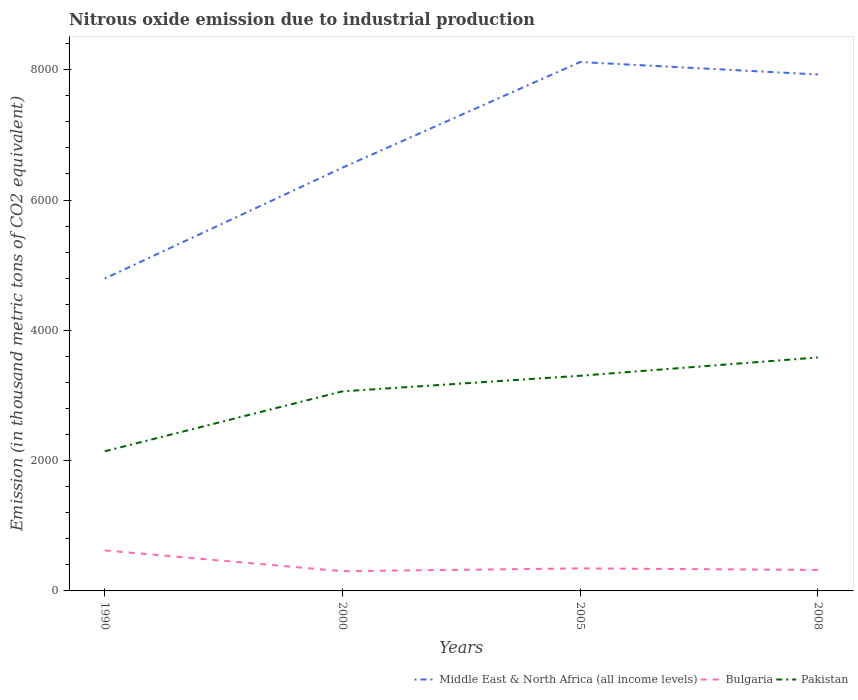How many different coloured lines are there?
Make the answer very short. 3. Is the number of lines equal to the number of legend labels?
Give a very brief answer. Yes. Across all years, what is the maximum amount of nitrous oxide emitted in Bulgaria?
Give a very brief answer. 302.6. In which year was the amount of nitrous oxide emitted in Bulgaria maximum?
Your response must be concise. 2000. What is the total amount of nitrous oxide emitted in Bulgaria in the graph?
Your answer should be compact. -19.4. What is the difference between the highest and the second highest amount of nitrous oxide emitted in Bulgaria?
Make the answer very short. 319.4. What is the difference between the highest and the lowest amount of nitrous oxide emitted in Pakistan?
Ensure brevity in your answer.  3. What is the difference between two consecutive major ticks on the Y-axis?
Make the answer very short. 2000. Are the values on the major ticks of Y-axis written in scientific E-notation?
Make the answer very short. No. Does the graph contain any zero values?
Ensure brevity in your answer.  No. What is the title of the graph?
Your response must be concise. Nitrous oxide emission due to industrial production. What is the label or title of the X-axis?
Provide a succinct answer. Years. What is the label or title of the Y-axis?
Your answer should be very brief. Emission (in thousand metric tons of CO2 equivalent). What is the Emission (in thousand metric tons of CO2 equivalent) in Middle East & North Africa (all income levels) in 1990?
Offer a very short reply. 4795.2. What is the Emission (in thousand metric tons of CO2 equivalent) in Bulgaria in 1990?
Your answer should be very brief. 622. What is the Emission (in thousand metric tons of CO2 equivalent) in Pakistan in 1990?
Offer a terse response. 2143.8. What is the Emission (in thousand metric tons of CO2 equivalent) of Middle East & North Africa (all income levels) in 2000?
Your answer should be very brief. 6497. What is the Emission (in thousand metric tons of CO2 equivalent) of Bulgaria in 2000?
Provide a short and direct response. 302.6. What is the Emission (in thousand metric tons of CO2 equivalent) in Pakistan in 2000?
Offer a terse response. 3063.5. What is the Emission (in thousand metric tons of CO2 equivalent) in Middle East & North Africa (all income levels) in 2005?
Provide a succinct answer. 8118.6. What is the Emission (in thousand metric tons of CO2 equivalent) of Bulgaria in 2005?
Your answer should be very brief. 345.8. What is the Emission (in thousand metric tons of CO2 equivalent) of Pakistan in 2005?
Keep it short and to the point. 3302.9. What is the Emission (in thousand metric tons of CO2 equivalent) of Middle East & North Africa (all income levels) in 2008?
Offer a terse response. 7927.7. What is the Emission (in thousand metric tons of CO2 equivalent) in Bulgaria in 2008?
Your response must be concise. 322. What is the Emission (in thousand metric tons of CO2 equivalent) in Pakistan in 2008?
Your answer should be compact. 3584. Across all years, what is the maximum Emission (in thousand metric tons of CO2 equivalent) in Middle East & North Africa (all income levels)?
Make the answer very short. 8118.6. Across all years, what is the maximum Emission (in thousand metric tons of CO2 equivalent) of Bulgaria?
Offer a very short reply. 622. Across all years, what is the maximum Emission (in thousand metric tons of CO2 equivalent) in Pakistan?
Your answer should be very brief. 3584. Across all years, what is the minimum Emission (in thousand metric tons of CO2 equivalent) in Middle East & North Africa (all income levels)?
Give a very brief answer. 4795.2. Across all years, what is the minimum Emission (in thousand metric tons of CO2 equivalent) of Bulgaria?
Offer a terse response. 302.6. Across all years, what is the minimum Emission (in thousand metric tons of CO2 equivalent) of Pakistan?
Your response must be concise. 2143.8. What is the total Emission (in thousand metric tons of CO2 equivalent) in Middle East & North Africa (all income levels) in the graph?
Your answer should be compact. 2.73e+04. What is the total Emission (in thousand metric tons of CO2 equivalent) of Bulgaria in the graph?
Your response must be concise. 1592.4. What is the total Emission (in thousand metric tons of CO2 equivalent) in Pakistan in the graph?
Your answer should be very brief. 1.21e+04. What is the difference between the Emission (in thousand metric tons of CO2 equivalent) of Middle East & North Africa (all income levels) in 1990 and that in 2000?
Provide a succinct answer. -1701.8. What is the difference between the Emission (in thousand metric tons of CO2 equivalent) of Bulgaria in 1990 and that in 2000?
Offer a very short reply. 319.4. What is the difference between the Emission (in thousand metric tons of CO2 equivalent) of Pakistan in 1990 and that in 2000?
Your response must be concise. -919.7. What is the difference between the Emission (in thousand metric tons of CO2 equivalent) of Middle East & North Africa (all income levels) in 1990 and that in 2005?
Make the answer very short. -3323.4. What is the difference between the Emission (in thousand metric tons of CO2 equivalent) of Bulgaria in 1990 and that in 2005?
Ensure brevity in your answer.  276.2. What is the difference between the Emission (in thousand metric tons of CO2 equivalent) of Pakistan in 1990 and that in 2005?
Your answer should be very brief. -1159.1. What is the difference between the Emission (in thousand metric tons of CO2 equivalent) in Middle East & North Africa (all income levels) in 1990 and that in 2008?
Keep it short and to the point. -3132.5. What is the difference between the Emission (in thousand metric tons of CO2 equivalent) of Bulgaria in 1990 and that in 2008?
Make the answer very short. 300. What is the difference between the Emission (in thousand metric tons of CO2 equivalent) of Pakistan in 1990 and that in 2008?
Give a very brief answer. -1440.2. What is the difference between the Emission (in thousand metric tons of CO2 equivalent) in Middle East & North Africa (all income levels) in 2000 and that in 2005?
Keep it short and to the point. -1621.6. What is the difference between the Emission (in thousand metric tons of CO2 equivalent) of Bulgaria in 2000 and that in 2005?
Your answer should be compact. -43.2. What is the difference between the Emission (in thousand metric tons of CO2 equivalent) in Pakistan in 2000 and that in 2005?
Offer a very short reply. -239.4. What is the difference between the Emission (in thousand metric tons of CO2 equivalent) in Middle East & North Africa (all income levels) in 2000 and that in 2008?
Your answer should be compact. -1430.7. What is the difference between the Emission (in thousand metric tons of CO2 equivalent) in Bulgaria in 2000 and that in 2008?
Offer a very short reply. -19.4. What is the difference between the Emission (in thousand metric tons of CO2 equivalent) in Pakistan in 2000 and that in 2008?
Keep it short and to the point. -520.5. What is the difference between the Emission (in thousand metric tons of CO2 equivalent) in Middle East & North Africa (all income levels) in 2005 and that in 2008?
Offer a terse response. 190.9. What is the difference between the Emission (in thousand metric tons of CO2 equivalent) in Bulgaria in 2005 and that in 2008?
Offer a terse response. 23.8. What is the difference between the Emission (in thousand metric tons of CO2 equivalent) of Pakistan in 2005 and that in 2008?
Your answer should be very brief. -281.1. What is the difference between the Emission (in thousand metric tons of CO2 equivalent) of Middle East & North Africa (all income levels) in 1990 and the Emission (in thousand metric tons of CO2 equivalent) of Bulgaria in 2000?
Ensure brevity in your answer.  4492.6. What is the difference between the Emission (in thousand metric tons of CO2 equivalent) of Middle East & North Africa (all income levels) in 1990 and the Emission (in thousand metric tons of CO2 equivalent) of Pakistan in 2000?
Keep it short and to the point. 1731.7. What is the difference between the Emission (in thousand metric tons of CO2 equivalent) of Bulgaria in 1990 and the Emission (in thousand metric tons of CO2 equivalent) of Pakistan in 2000?
Your answer should be compact. -2441.5. What is the difference between the Emission (in thousand metric tons of CO2 equivalent) in Middle East & North Africa (all income levels) in 1990 and the Emission (in thousand metric tons of CO2 equivalent) in Bulgaria in 2005?
Make the answer very short. 4449.4. What is the difference between the Emission (in thousand metric tons of CO2 equivalent) of Middle East & North Africa (all income levels) in 1990 and the Emission (in thousand metric tons of CO2 equivalent) of Pakistan in 2005?
Your answer should be compact. 1492.3. What is the difference between the Emission (in thousand metric tons of CO2 equivalent) of Bulgaria in 1990 and the Emission (in thousand metric tons of CO2 equivalent) of Pakistan in 2005?
Provide a succinct answer. -2680.9. What is the difference between the Emission (in thousand metric tons of CO2 equivalent) in Middle East & North Africa (all income levels) in 1990 and the Emission (in thousand metric tons of CO2 equivalent) in Bulgaria in 2008?
Offer a terse response. 4473.2. What is the difference between the Emission (in thousand metric tons of CO2 equivalent) in Middle East & North Africa (all income levels) in 1990 and the Emission (in thousand metric tons of CO2 equivalent) in Pakistan in 2008?
Your response must be concise. 1211.2. What is the difference between the Emission (in thousand metric tons of CO2 equivalent) in Bulgaria in 1990 and the Emission (in thousand metric tons of CO2 equivalent) in Pakistan in 2008?
Offer a terse response. -2962. What is the difference between the Emission (in thousand metric tons of CO2 equivalent) in Middle East & North Africa (all income levels) in 2000 and the Emission (in thousand metric tons of CO2 equivalent) in Bulgaria in 2005?
Keep it short and to the point. 6151.2. What is the difference between the Emission (in thousand metric tons of CO2 equivalent) of Middle East & North Africa (all income levels) in 2000 and the Emission (in thousand metric tons of CO2 equivalent) of Pakistan in 2005?
Your response must be concise. 3194.1. What is the difference between the Emission (in thousand metric tons of CO2 equivalent) in Bulgaria in 2000 and the Emission (in thousand metric tons of CO2 equivalent) in Pakistan in 2005?
Ensure brevity in your answer.  -3000.3. What is the difference between the Emission (in thousand metric tons of CO2 equivalent) of Middle East & North Africa (all income levels) in 2000 and the Emission (in thousand metric tons of CO2 equivalent) of Bulgaria in 2008?
Offer a terse response. 6175. What is the difference between the Emission (in thousand metric tons of CO2 equivalent) of Middle East & North Africa (all income levels) in 2000 and the Emission (in thousand metric tons of CO2 equivalent) of Pakistan in 2008?
Offer a terse response. 2913. What is the difference between the Emission (in thousand metric tons of CO2 equivalent) in Bulgaria in 2000 and the Emission (in thousand metric tons of CO2 equivalent) in Pakistan in 2008?
Your answer should be compact. -3281.4. What is the difference between the Emission (in thousand metric tons of CO2 equivalent) in Middle East & North Africa (all income levels) in 2005 and the Emission (in thousand metric tons of CO2 equivalent) in Bulgaria in 2008?
Your response must be concise. 7796.6. What is the difference between the Emission (in thousand metric tons of CO2 equivalent) of Middle East & North Africa (all income levels) in 2005 and the Emission (in thousand metric tons of CO2 equivalent) of Pakistan in 2008?
Provide a short and direct response. 4534.6. What is the difference between the Emission (in thousand metric tons of CO2 equivalent) of Bulgaria in 2005 and the Emission (in thousand metric tons of CO2 equivalent) of Pakistan in 2008?
Give a very brief answer. -3238.2. What is the average Emission (in thousand metric tons of CO2 equivalent) in Middle East & North Africa (all income levels) per year?
Provide a succinct answer. 6834.62. What is the average Emission (in thousand metric tons of CO2 equivalent) of Bulgaria per year?
Provide a short and direct response. 398.1. What is the average Emission (in thousand metric tons of CO2 equivalent) in Pakistan per year?
Offer a very short reply. 3023.55. In the year 1990, what is the difference between the Emission (in thousand metric tons of CO2 equivalent) of Middle East & North Africa (all income levels) and Emission (in thousand metric tons of CO2 equivalent) of Bulgaria?
Offer a very short reply. 4173.2. In the year 1990, what is the difference between the Emission (in thousand metric tons of CO2 equivalent) in Middle East & North Africa (all income levels) and Emission (in thousand metric tons of CO2 equivalent) in Pakistan?
Give a very brief answer. 2651.4. In the year 1990, what is the difference between the Emission (in thousand metric tons of CO2 equivalent) in Bulgaria and Emission (in thousand metric tons of CO2 equivalent) in Pakistan?
Offer a very short reply. -1521.8. In the year 2000, what is the difference between the Emission (in thousand metric tons of CO2 equivalent) of Middle East & North Africa (all income levels) and Emission (in thousand metric tons of CO2 equivalent) of Bulgaria?
Give a very brief answer. 6194.4. In the year 2000, what is the difference between the Emission (in thousand metric tons of CO2 equivalent) in Middle East & North Africa (all income levels) and Emission (in thousand metric tons of CO2 equivalent) in Pakistan?
Your answer should be very brief. 3433.5. In the year 2000, what is the difference between the Emission (in thousand metric tons of CO2 equivalent) of Bulgaria and Emission (in thousand metric tons of CO2 equivalent) of Pakistan?
Make the answer very short. -2760.9. In the year 2005, what is the difference between the Emission (in thousand metric tons of CO2 equivalent) of Middle East & North Africa (all income levels) and Emission (in thousand metric tons of CO2 equivalent) of Bulgaria?
Your response must be concise. 7772.8. In the year 2005, what is the difference between the Emission (in thousand metric tons of CO2 equivalent) of Middle East & North Africa (all income levels) and Emission (in thousand metric tons of CO2 equivalent) of Pakistan?
Make the answer very short. 4815.7. In the year 2005, what is the difference between the Emission (in thousand metric tons of CO2 equivalent) of Bulgaria and Emission (in thousand metric tons of CO2 equivalent) of Pakistan?
Offer a very short reply. -2957.1. In the year 2008, what is the difference between the Emission (in thousand metric tons of CO2 equivalent) of Middle East & North Africa (all income levels) and Emission (in thousand metric tons of CO2 equivalent) of Bulgaria?
Your answer should be compact. 7605.7. In the year 2008, what is the difference between the Emission (in thousand metric tons of CO2 equivalent) in Middle East & North Africa (all income levels) and Emission (in thousand metric tons of CO2 equivalent) in Pakistan?
Provide a short and direct response. 4343.7. In the year 2008, what is the difference between the Emission (in thousand metric tons of CO2 equivalent) in Bulgaria and Emission (in thousand metric tons of CO2 equivalent) in Pakistan?
Make the answer very short. -3262. What is the ratio of the Emission (in thousand metric tons of CO2 equivalent) in Middle East & North Africa (all income levels) in 1990 to that in 2000?
Provide a short and direct response. 0.74. What is the ratio of the Emission (in thousand metric tons of CO2 equivalent) in Bulgaria in 1990 to that in 2000?
Your response must be concise. 2.06. What is the ratio of the Emission (in thousand metric tons of CO2 equivalent) in Pakistan in 1990 to that in 2000?
Keep it short and to the point. 0.7. What is the ratio of the Emission (in thousand metric tons of CO2 equivalent) of Middle East & North Africa (all income levels) in 1990 to that in 2005?
Offer a terse response. 0.59. What is the ratio of the Emission (in thousand metric tons of CO2 equivalent) in Bulgaria in 1990 to that in 2005?
Your answer should be compact. 1.8. What is the ratio of the Emission (in thousand metric tons of CO2 equivalent) of Pakistan in 1990 to that in 2005?
Provide a succinct answer. 0.65. What is the ratio of the Emission (in thousand metric tons of CO2 equivalent) in Middle East & North Africa (all income levels) in 1990 to that in 2008?
Your answer should be compact. 0.6. What is the ratio of the Emission (in thousand metric tons of CO2 equivalent) of Bulgaria in 1990 to that in 2008?
Your answer should be very brief. 1.93. What is the ratio of the Emission (in thousand metric tons of CO2 equivalent) of Pakistan in 1990 to that in 2008?
Provide a short and direct response. 0.6. What is the ratio of the Emission (in thousand metric tons of CO2 equivalent) in Middle East & North Africa (all income levels) in 2000 to that in 2005?
Make the answer very short. 0.8. What is the ratio of the Emission (in thousand metric tons of CO2 equivalent) of Bulgaria in 2000 to that in 2005?
Offer a terse response. 0.88. What is the ratio of the Emission (in thousand metric tons of CO2 equivalent) of Pakistan in 2000 to that in 2005?
Your answer should be very brief. 0.93. What is the ratio of the Emission (in thousand metric tons of CO2 equivalent) in Middle East & North Africa (all income levels) in 2000 to that in 2008?
Give a very brief answer. 0.82. What is the ratio of the Emission (in thousand metric tons of CO2 equivalent) in Bulgaria in 2000 to that in 2008?
Make the answer very short. 0.94. What is the ratio of the Emission (in thousand metric tons of CO2 equivalent) in Pakistan in 2000 to that in 2008?
Your response must be concise. 0.85. What is the ratio of the Emission (in thousand metric tons of CO2 equivalent) of Middle East & North Africa (all income levels) in 2005 to that in 2008?
Keep it short and to the point. 1.02. What is the ratio of the Emission (in thousand metric tons of CO2 equivalent) of Bulgaria in 2005 to that in 2008?
Offer a very short reply. 1.07. What is the ratio of the Emission (in thousand metric tons of CO2 equivalent) in Pakistan in 2005 to that in 2008?
Provide a succinct answer. 0.92. What is the difference between the highest and the second highest Emission (in thousand metric tons of CO2 equivalent) of Middle East & North Africa (all income levels)?
Keep it short and to the point. 190.9. What is the difference between the highest and the second highest Emission (in thousand metric tons of CO2 equivalent) of Bulgaria?
Your answer should be very brief. 276.2. What is the difference between the highest and the second highest Emission (in thousand metric tons of CO2 equivalent) of Pakistan?
Ensure brevity in your answer.  281.1. What is the difference between the highest and the lowest Emission (in thousand metric tons of CO2 equivalent) in Middle East & North Africa (all income levels)?
Offer a terse response. 3323.4. What is the difference between the highest and the lowest Emission (in thousand metric tons of CO2 equivalent) of Bulgaria?
Your answer should be very brief. 319.4. What is the difference between the highest and the lowest Emission (in thousand metric tons of CO2 equivalent) in Pakistan?
Offer a terse response. 1440.2. 